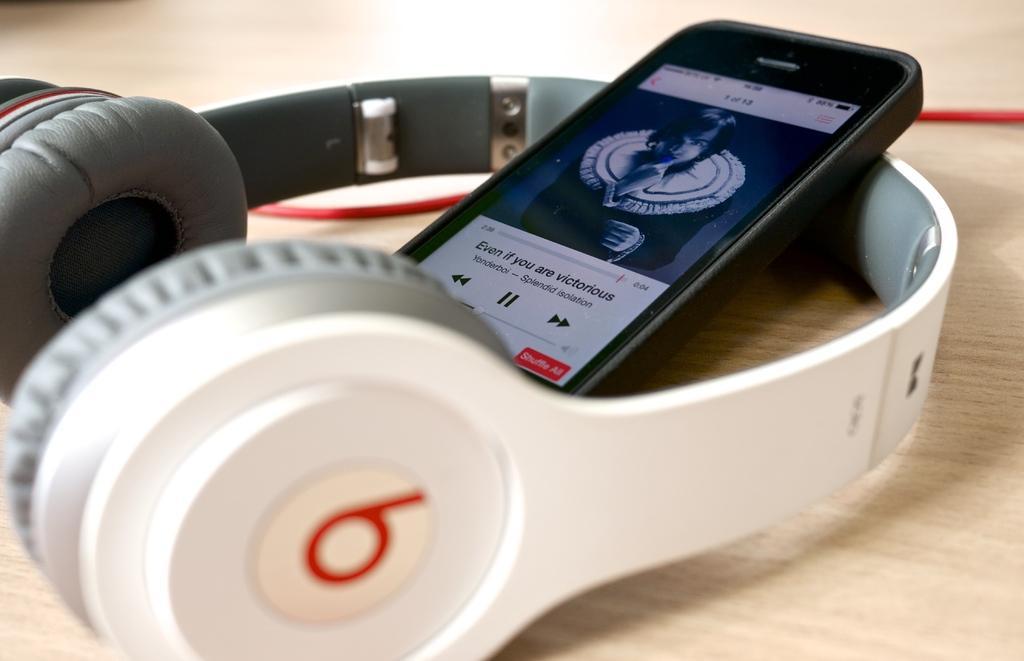How would you summarize this image in a sentence or two? In this image we can see a mobile placed on a headset on the table. 